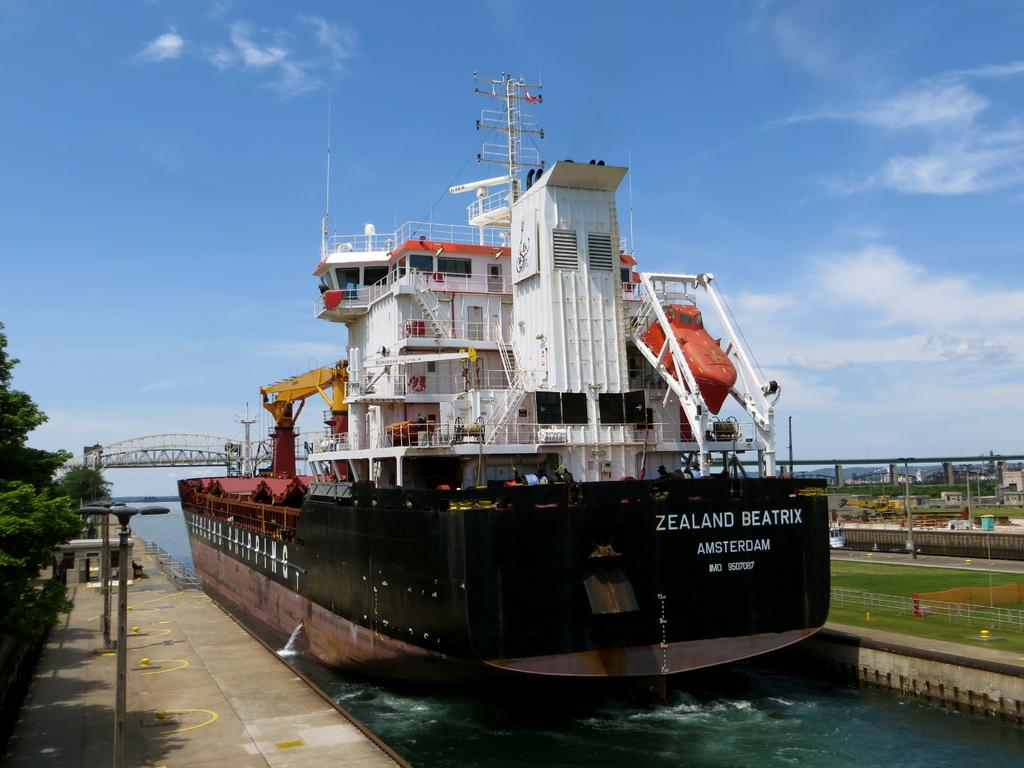<image>
Offer a succinct explanation of the picture presented. The Zealand Beatrix Ship is docked in the harbor. 